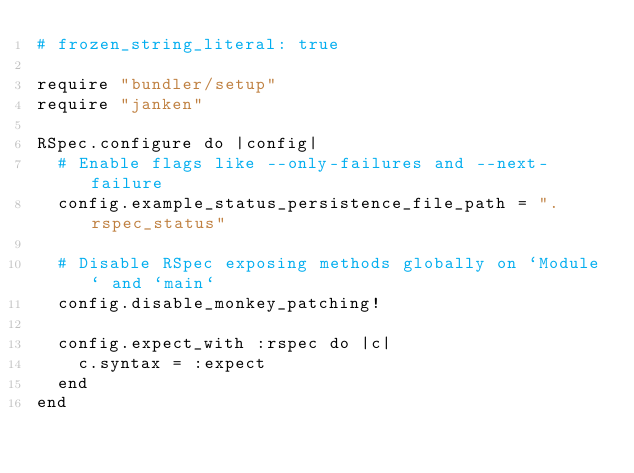Convert code to text. <code><loc_0><loc_0><loc_500><loc_500><_Ruby_># frozen_string_literal: true

require "bundler/setup"
require "janken"

RSpec.configure do |config|
  # Enable flags like --only-failures and --next-failure
  config.example_status_persistence_file_path = ".rspec_status"

  # Disable RSpec exposing methods globally on `Module` and `main`
  config.disable_monkey_patching!

  config.expect_with :rspec do |c|
    c.syntax = :expect
  end
end
</code> 